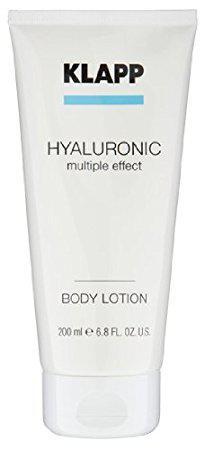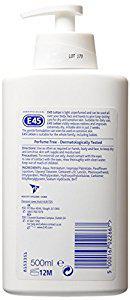The first image is the image on the left, the second image is the image on the right. For the images displayed, is the sentence "Left image shows a product with a pump-top dispenser." factually correct? Answer yes or no. No. The first image is the image on the left, the second image is the image on the right. Given the left and right images, does the statement "Only one white bottle is squat and rectangular shaped with rounded edges and a pump top." hold true? Answer yes or no. Yes. 